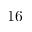<formula> <loc_0><loc_0><loc_500><loc_500>1 6</formula> 